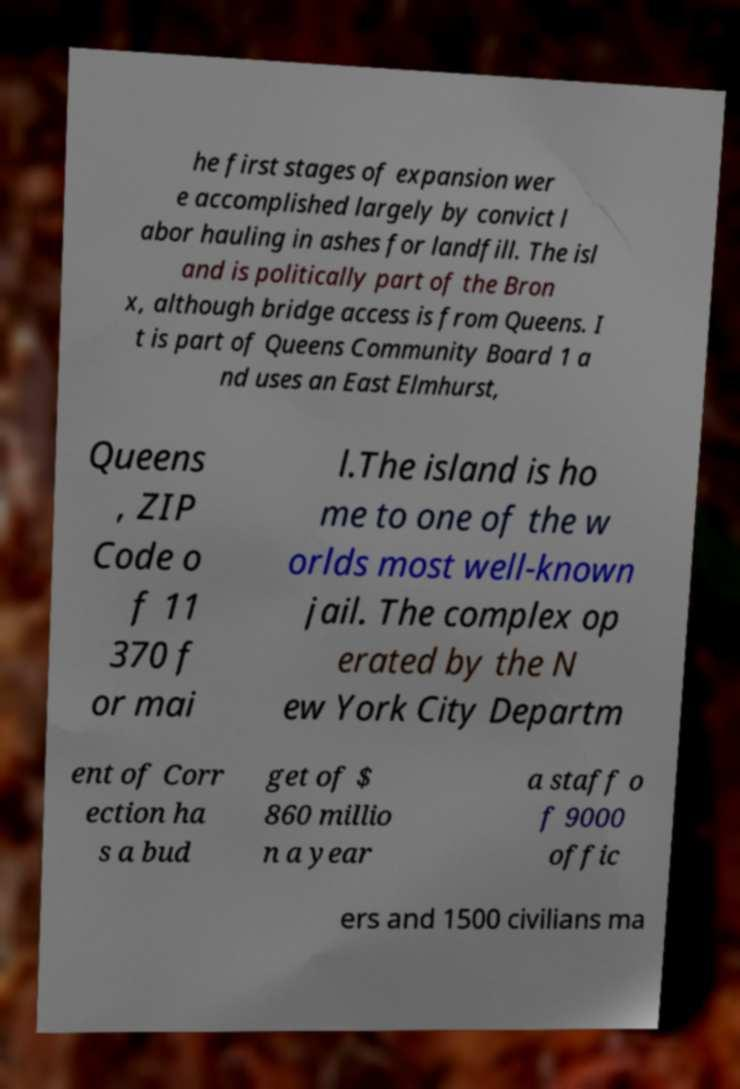What messages or text are displayed in this image? I need them in a readable, typed format. he first stages of expansion wer e accomplished largely by convict l abor hauling in ashes for landfill. The isl and is politically part of the Bron x, although bridge access is from Queens. I t is part of Queens Community Board 1 a nd uses an East Elmhurst, Queens , ZIP Code o f 11 370 f or mai l.The island is ho me to one of the w orlds most well-known jail. The complex op erated by the N ew York City Departm ent of Corr ection ha s a bud get of $ 860 millio n a year a staff o f 9000 offic ers and 1500 civilians ma 